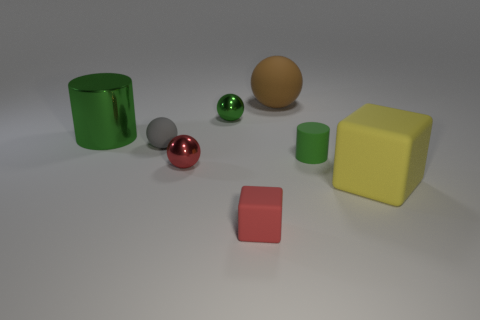How many cyan metallic spheres are the same size as the yellow block?
Offer a terse response. 0. There is a shiny ball that is left of the tiny green ball; what number of yellow things are behind it?
Your answer should be compact. 0. What is the size of the rubber object that is both in front of the green matte object and on the right side of the large brown matte thing?
Offer a terse response. Large. Is the number of tiny blocks greater than the number of red objects?
Give a very brief answer. No. Are there any rubber blocks that have the same color as the small matte cylinder?
Keep it short and to the point. No. Does the block that is left of the yellow matte object have the same size as the tiny gray rubber thing?
Your response must be concise. Yes. Is the number of small red balls less than the number of red cylinders?
Ensure brevity in your answer.  No. Are there any small red spheres made of the same material as the large green thing?
Keep it short and to the point. Yes. The small metallic thing that is in front of the tiny rubber ball has what shape?
Provide a succinct answer. Sphere. There is a cylinder that is on the right side of the large brown object; is its color the same as the metallic cylinder?
Provide a succinct answer. Yes. 